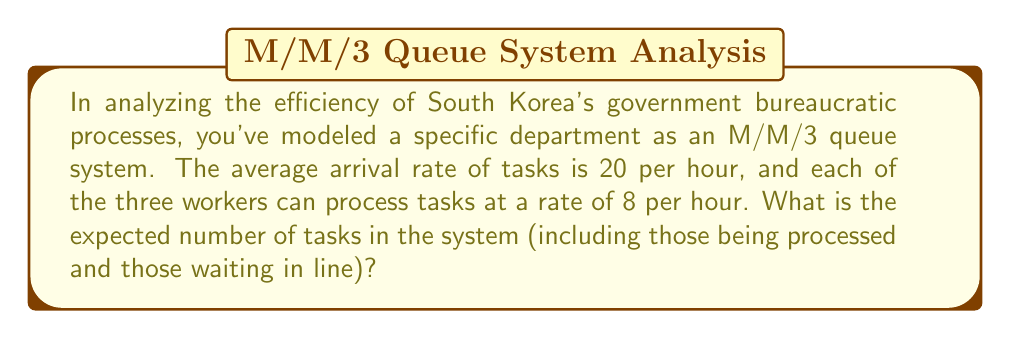What is the answer to this math problem? To solve this problem, we'll use the M/M/3 queuing model and follow these steps:

1. Identify the parameters:
   - Arrival rate: $\lambda = 20$ tasks/hour
   - Service rate per worker: $\mu = 8$ tasks/hour
   - Number of servers: $c = 3$

2. Calculate the system utilization $\rho$:
   $$\rho = \frac{\lambda}{c\mu} = \frac{20}{3 \cdot 8} = \frac{5}{6} \approx 0.833$$

3. Calculate the probability of an empty system $P_0$:
   $$P_0 = \left[\sum_{n=0}^{c-1}\frac{(c\rho)^n}{n!} + \frac{(c\rho)^c}{c!(1-\rho)}\right]^{-1}$$
   $$P_0 = \left[1 + \frac{20}{1!} + \frac{20^2}{2!} + \frac{20^3}{3!(3-\frac{5}{3})}\right]^{-1} \approx 0.00248$$

4. Calculate the expected number of tasks in the queue $L_q$:
   $$L_q = \frac{P_0(c\rho)^c\rho}{c!(1-\rho)^2} = \frac{0.00248 \cdot 20^3 \cdot \frac{5}{6}}{3!(1-\frac{5}{6})^2} \approx 4.165$$

5. Calculate the expected number of tasks in the system $L$:
   $$L = L_q + c\rho = 4.165 + 3 \cdot \frac{5}{6} = 4.165 + 2.5 = 6.665$$

Therefore, the expected number of tasks in the system is approximately 6.665.
Answer: 6.665 tasks 